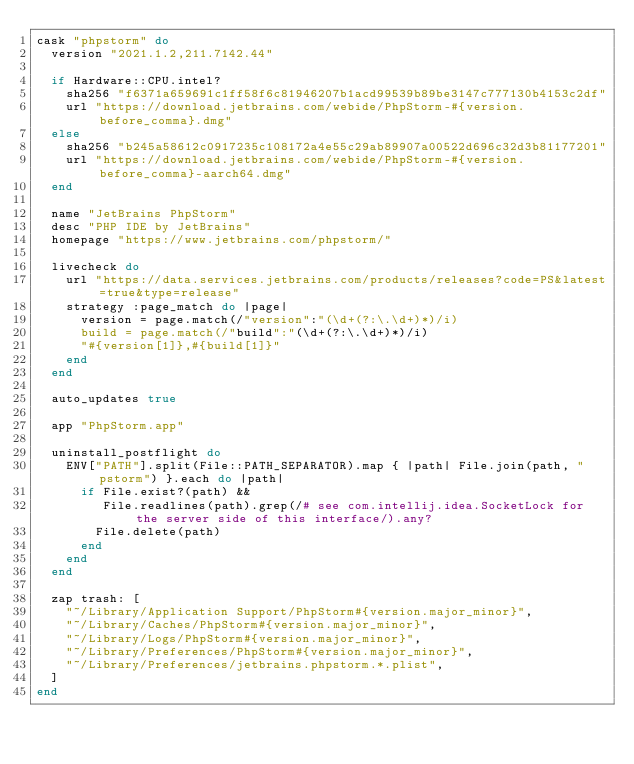<code> <loc_0><loc_0><loc_500><loc_500><_Ruby_>cask "phpstorm" do
  version "2021.1.2,211.7142.44"

  if Hardware::CPU.intel?
    sha256 "f6371a659691c1ff58f6c81946207b1acd99539b89be3147c777130b4153c2df"
    url "https://download.jetbrains.com/webide/PhpStorm-#{version.before_comma}.dmg"
  else
    sha256 "b245a58612c0917235c108172a4e55c29ab89907a00522d696c32d3b81177201"
    url "https://download.jetbrains.com/webide/PhpStorm-#{version.before_comma}-aarch64.dmg"
  end

  name "JetBrains PhpStorm"
  desc "PHP IDE by JetBrains"
  homepage "https://www.jetbrains.com/phpstorm/"

  livecheck do
    url "https://data.services.jetbrains.com/products/releases?code=PS&latest=true&type=release"
    strategy :page_match do |page|
      version = page.match(/"version":"(\d+(?:\.\d+)*)/i)
      build = page.match(/"build":"(\d+(?:\.\d+)*)/i)
      "#{version[1]},#{build[1]}"
    end
  end

  auto_updates true

  app "PhpStorm.app"

  uninstall_postflight do
    ENV["PATH"].split(File::PATH_SEPARATOR).map { |path| File.join(path, "pstorm") }.each do |path|
      if File.exist?(path) &&
         File.readlines(path).grep(/# see com.intellij.idea.SocketLock for the server side of this interface/).any?
        File.delete(path)
      end
    end
  end

  zap trash: [
    "~/Library/Application Support/PhpStorm#{version.major_minor}",
    "~/Library/Caches/PhpStorm#{version.major_minor}",
    "~/Library/Logs/PhpStorm#{version.major_minor}",
    "~/Library/Preferences/PhpStorm#{version.major_minor}",
    "~/Library/Preferences/jetbrains.phpstorm.*.plist",
  ]
end
</code> 